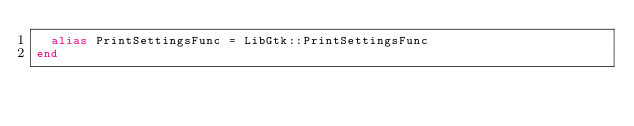Convert code to text. <code><loc_0><loc_0><loc_500><loc_500><_Crystal_>  alias PrintSettingsFunc = LibGtk::PrintSettingsFunc
end

</code> 